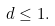<formula> <loc_0><loc_0><loc_500><loc_500>d \leq 1 .</formula> 